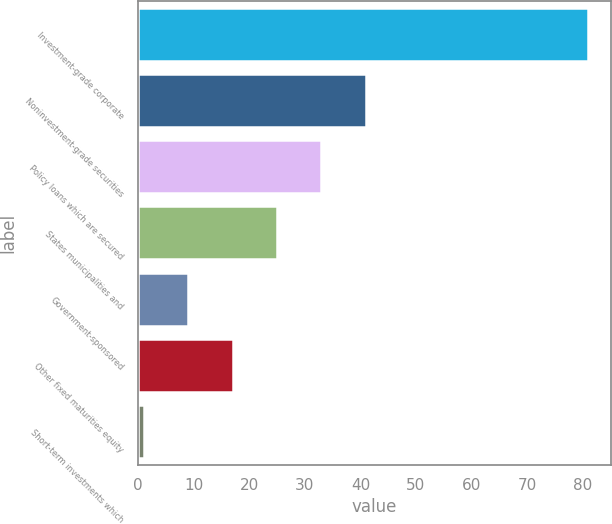Convert chart. <chart><loc_0><loc_0><loc_500><loc_500><bar_chart><fcel>Investment-grade corporate<fcel>Noninvestment-grade securities<fcel>Policy loans which are secured<fcel>States municipalities and<fcel>Government-sponsored<fcel>Other fixed maturities equity<fcel>Short-term investments which<nl><fcel>81<fcel>41<fcel>33<fcel>25<fcel>9<fcel>17<fcel>1<nl></chart> 